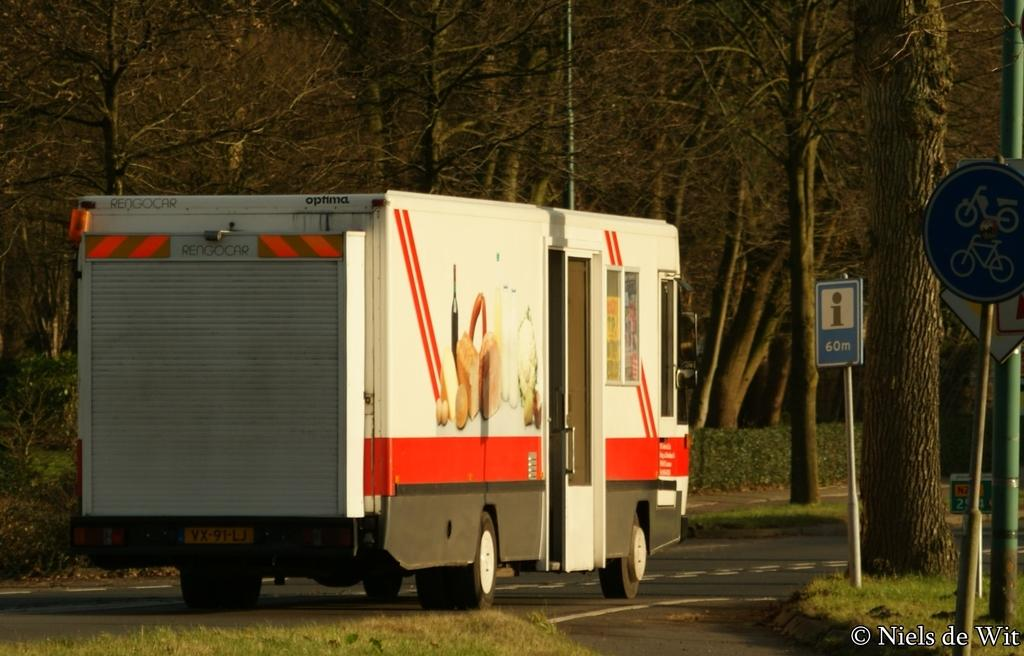What type of natural elements can be seen in the image? There are trees in the image. What is the main subject in the middle of the image? There is a truck in the middle of the image. What can be seen on the right side of the image? There are sign boards on the right side of the image. What type of metal is used to construct the quiver in the image? There is no quiver present in the image; it features trees, a truck, and sign boards. 